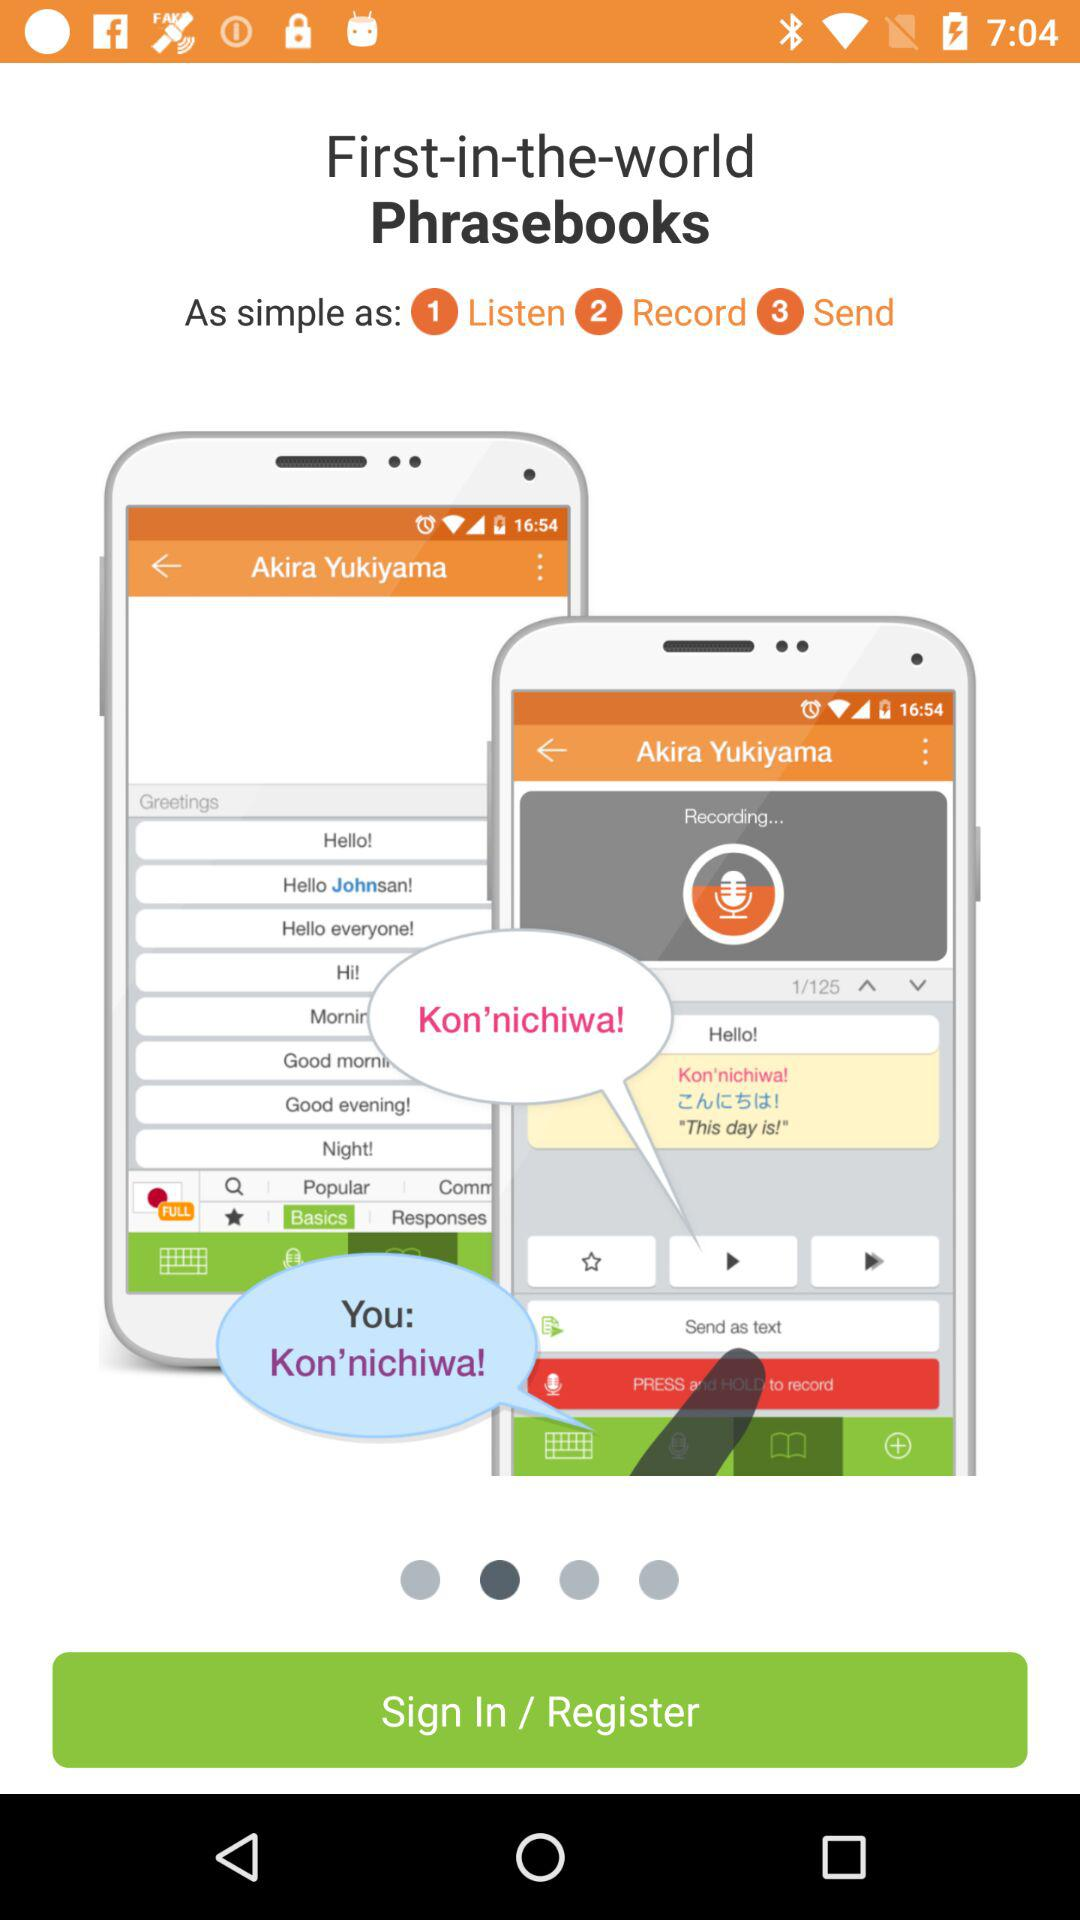At which step number is the "Send" option available? The "Send" option is available at the third step. 